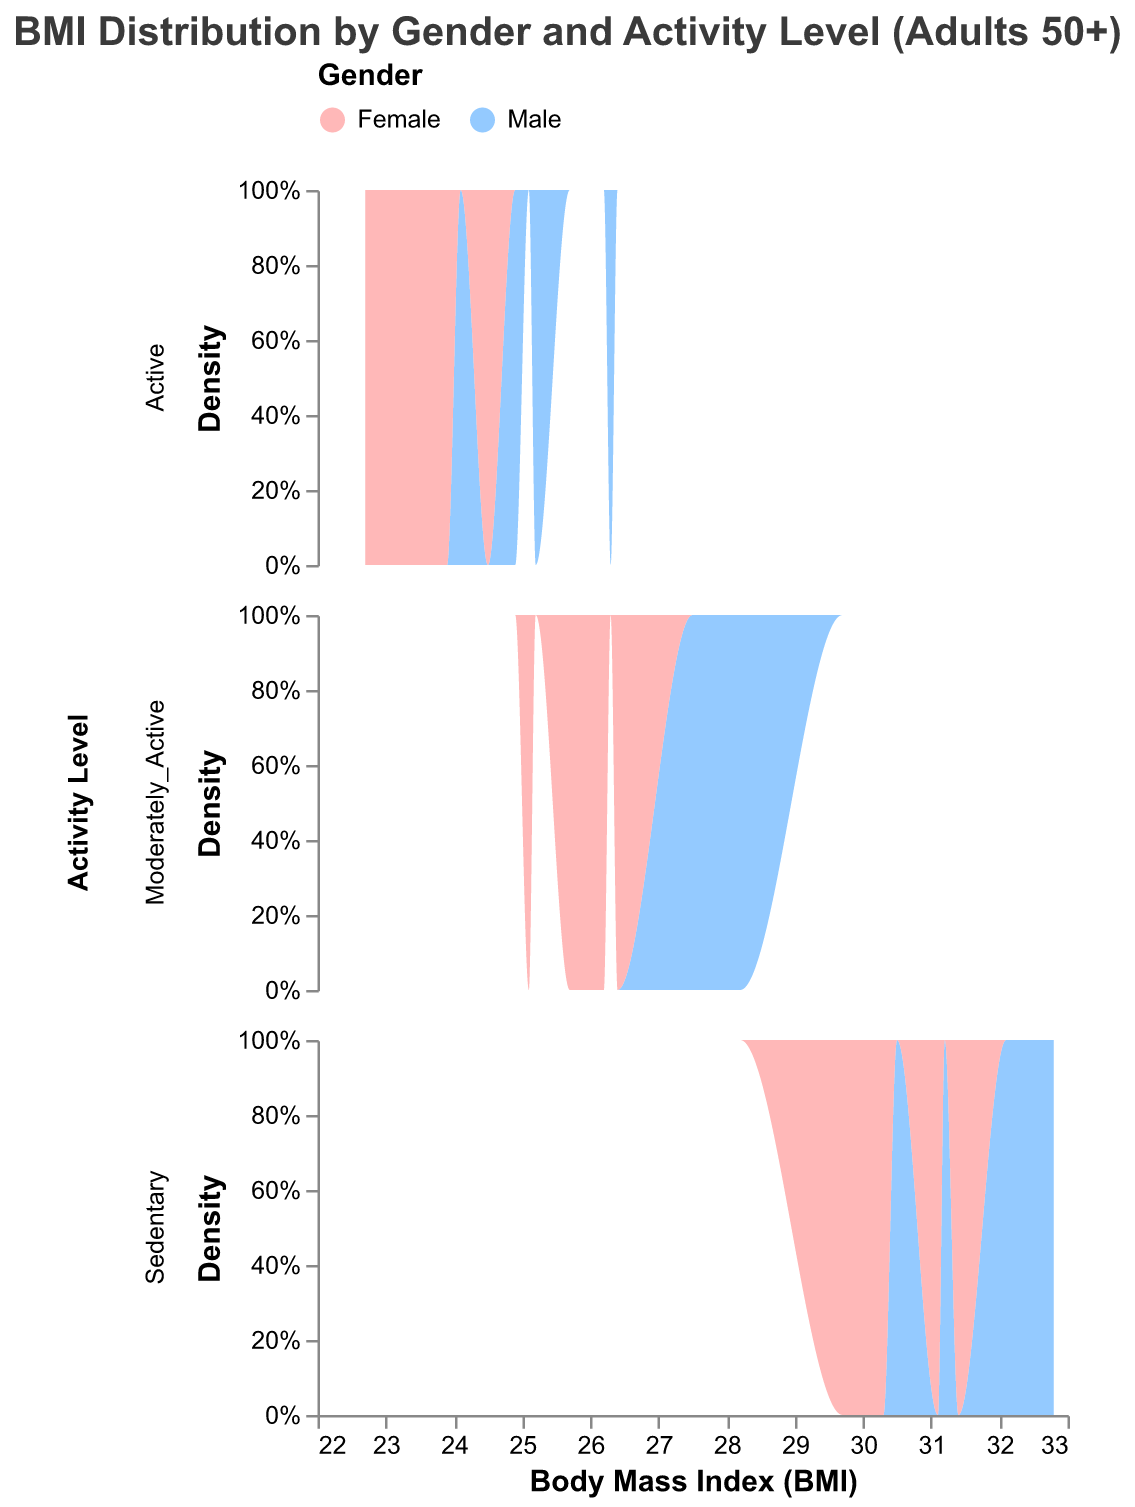What is the title of the subplot figure? The title of the plot is usually placed at the top and is intended to provide an overview of what the viewer is about to see. In this case, it reads "BMI Distribution by Gender and Activity Level (Adults 50+)."
Answer: BMI Distribution by Gender and Activity Level (Adults 50+) How many activity levels are represented in the subplot? Each row facet of the subplot represents a different activity level. From the data and the facet field, we can identify that there are three activity levels: Active, Moderately Active, and Sedentary.
Answer: 3 What color represents the Female gender in the plot? The legend at the top of the figure provides color coding for the genders. "Female" is represented by the color pink, with the exact shade being light pink.
Answer: Pink Which activity level shows the highest BMI density for males? By evaluating the density peaks of the Male density plot lines within each activity level facet (Active, Moderately Active, Sedentary), the highest peak appears within the Sedentary activity level.
Answer: Sedentary Compare the BMI distributions of males and females in the Active category. Which gender tends to have a higher BMI? By examining the density plots in the Active category, males have a distribution peak around higher BMI values compared to females.
Answer: Males In the Moderately Active category, which gender shows a wider spread of BMI values? Evaluating the width of the density plots in the Moderately Active category indicates that females have a more spread-out distribution.
Answer: Females What is the approximate BMI range covered by Sedentary females? Looking at the Sedentary female density plot, we can observe that the distribution starts slightly below 29.7 and goes beyond 31.4, indicating a range from about 29.7 to 31.4.
Answer: 29.7 to 31.4 Identify the trend observed in BMI values when moving from Active to Sedentary lifestyle for both genders. As we move from the Active to the Sedentary lifestyle, the density plots for both genders shift towards higher BMI values, indicating that more sedentary individuals typically have higher BMI.
Answer: Higher BMI values in Sedentary How does the BMI density curve of Moderately Active males compare to that of Sedentary males? The BMI density curve for Moderately Active males is more centered around lower BMI values compared to the BMI density curve for Sedentary males, which is more skewed to higher BMI values.
Answer: Lower BMI in Moderately Active males What is the BMI distribution pattern for the Active females compared to Moderately Active females? Comparing the density plots for Active and Moderately Active females, the distribution for Active females is more tightly grouped around lower BMI values, whereas Moderately Active females show a broader, slightly higher BMI range.
Answer: Lower BMI in Active females 